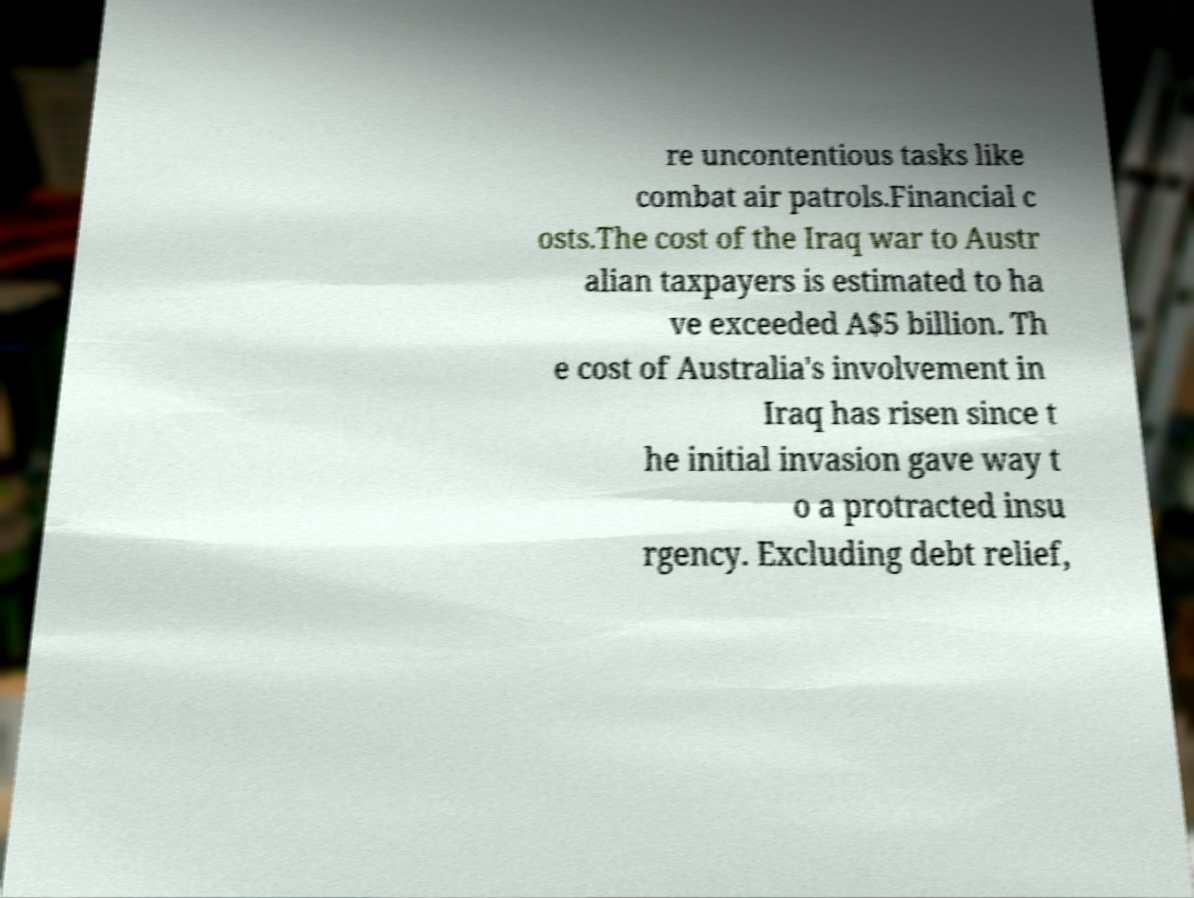For documentation purposes, I need the text within this image transcribed. Could you provide that? re uncontentious tasks like combat air patrols.Financial c osts.The cost of the Iraq war to Austr alian taxpayers is estimated to ha ve exceeded A$5 billion. Th e cost of Australia's involvement in Iraq has risen since t he initial invasion gave way t o a protracted insu rgency. Excluding debt relief, 